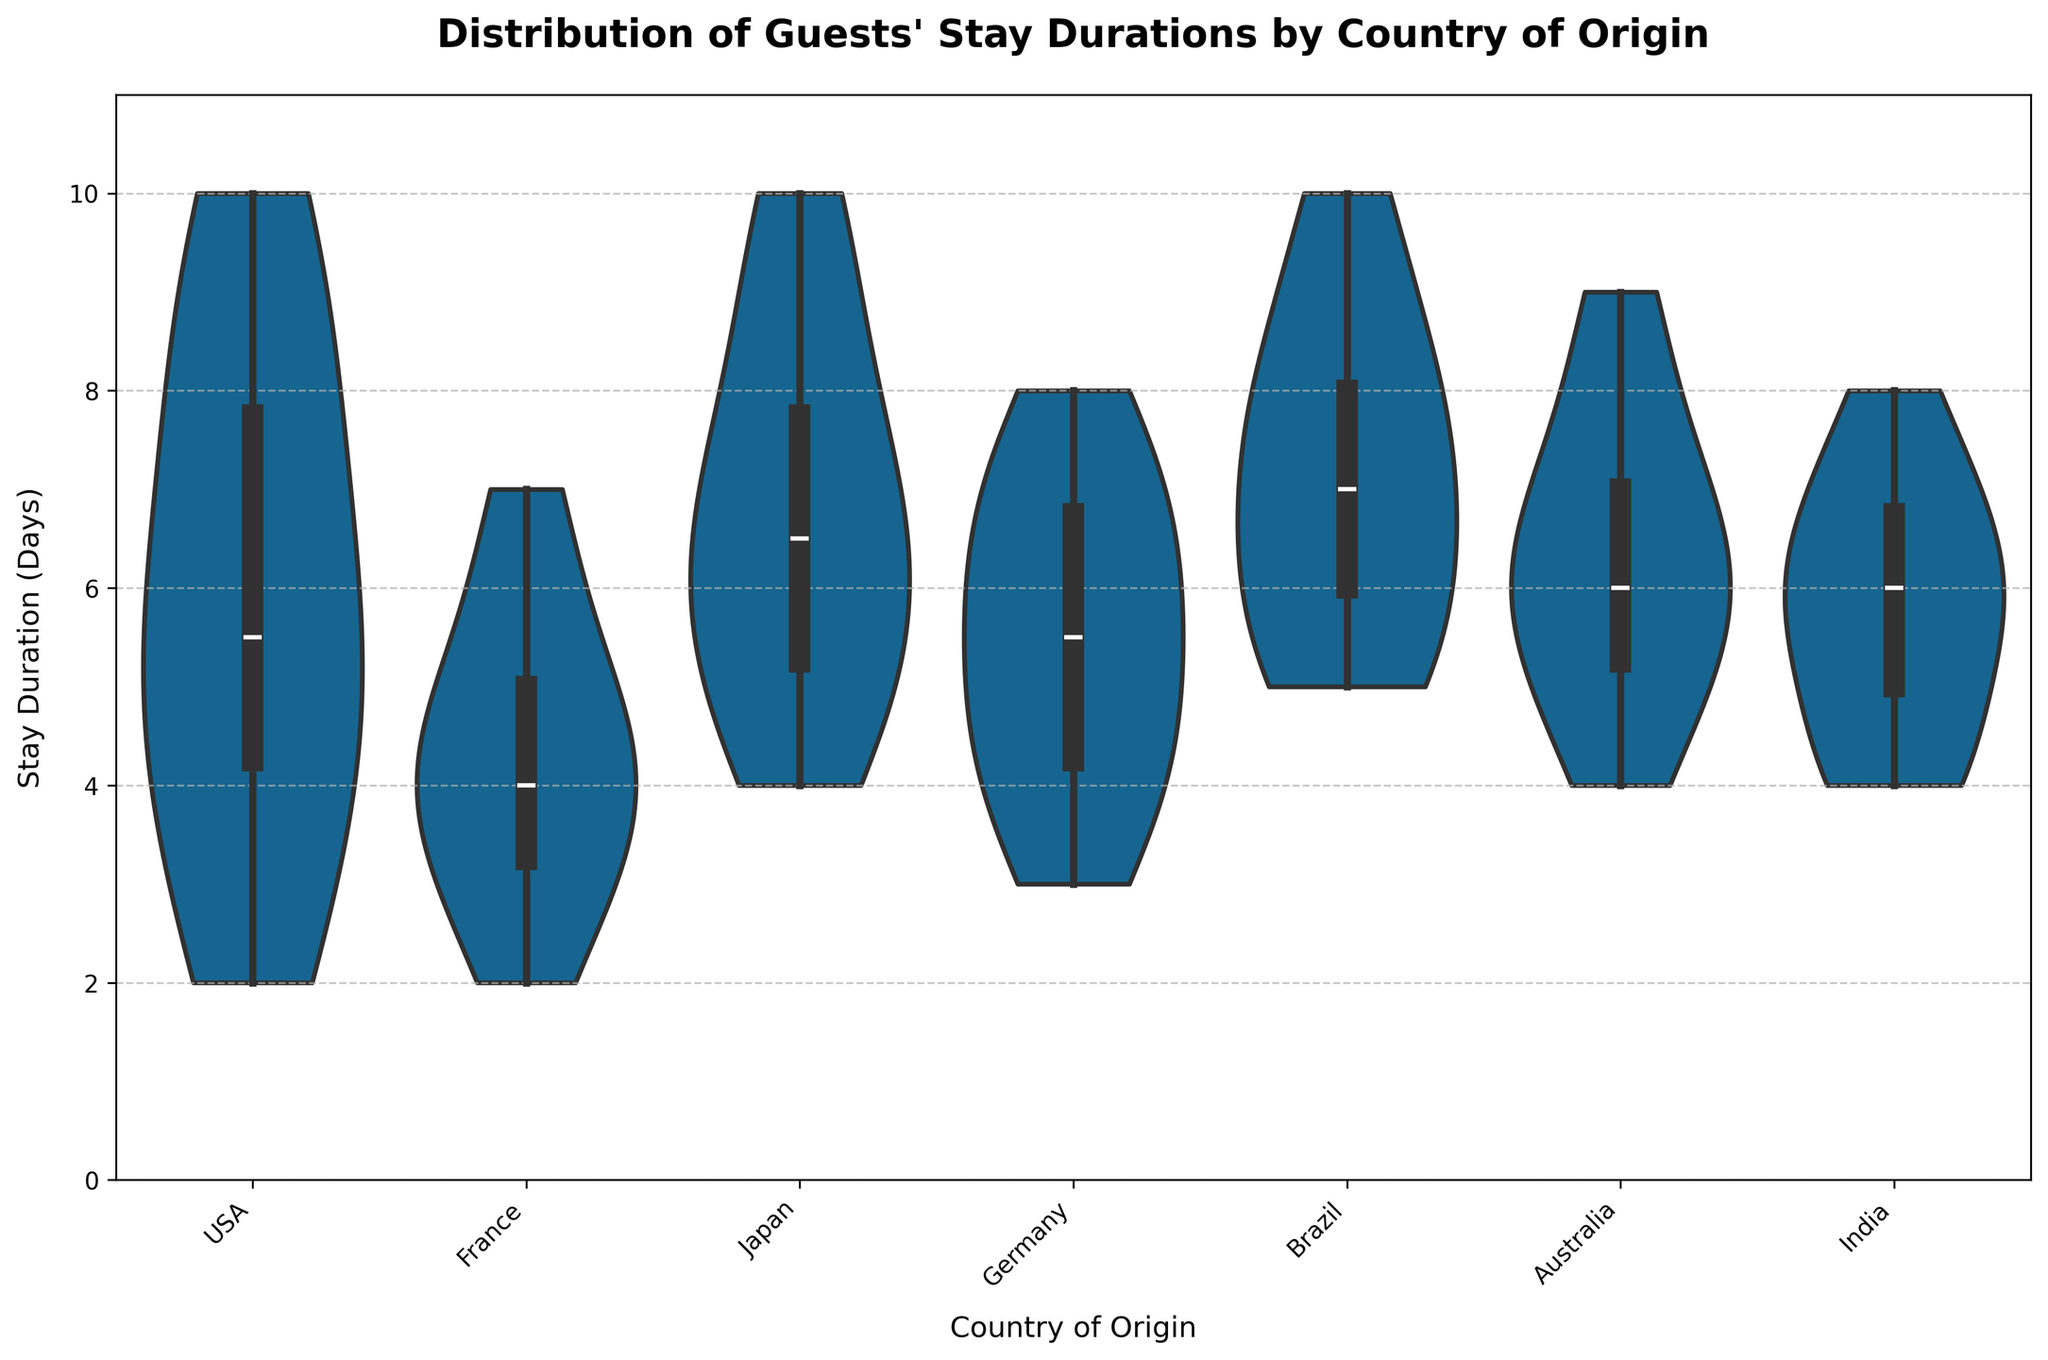What is the title of the plot? The title is located at the top center of the plot, which provides the main subject of the visualization.
Answer: Distribution of Guests' Stay Durations by Country of Origin How many countries are represented in the plot? Count the distinct categories on the x-axis, which represent each country of origin.
Answer: 7 Which country has the widest range of stay durations? Identify the country whose violin plot spans the largest interval on the y-axis, indicating the widest range of durations.
Answer: USA What is the median stay duration for guests from Japan? Look at the horizontal line inside the violin plot for Japan, which represents the median value.
Answer: 6.5 days Which country has the most concentrated stay durations around the median? Examine the violin plots and identify which has the smallest spread around its median line.
Answer: France Compare the median stay durations for Germany and Brazil. Which is higher? Check the median lines within the violin plots for Germany and Brazil and compare their positions on the y-axis.
Answer: Brazil What is the minimum stay duration recorded for guests from India? Find the lowest point within the violin plot for India, representing the minimum stay duration.
Answer: 4 days Which countries have guests with stay durations exceeding 9 days? Look for countries with violin plots that extend above 9 on the y-axis.
Answer: USA, Japan, Brazil, Australia What is the most common stay duration for guests from France? Identify the peak of the violin plot for France, where the density is highest.
Answer: 4 days Compare the overall shapes of the violin plots for Australia and France. What differences do you notice? Evaluate the distribution spreads and density peaks of the violin plots for Australia and France. Australia has a more symmetrical spread with multiple peaks, while France has a single, sharp peak around 4 days, indicating more uniform stays.
Answer: Australia: symmetrical, multiple peaks; France: sharp peak at 4 days 